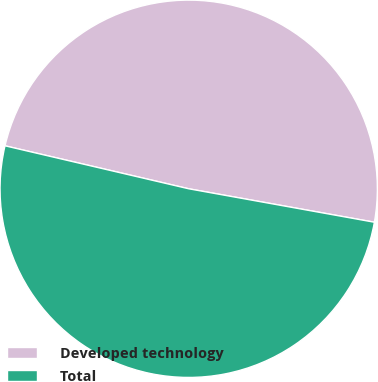Convert chart to OTSL. <chart><loc_0><loc_0><loc_500><loc_500><pie_chart><fcel>Developed technology<fcel>Total<nl><fcel>49.18%<fcel>50.82%<nl></chart> 